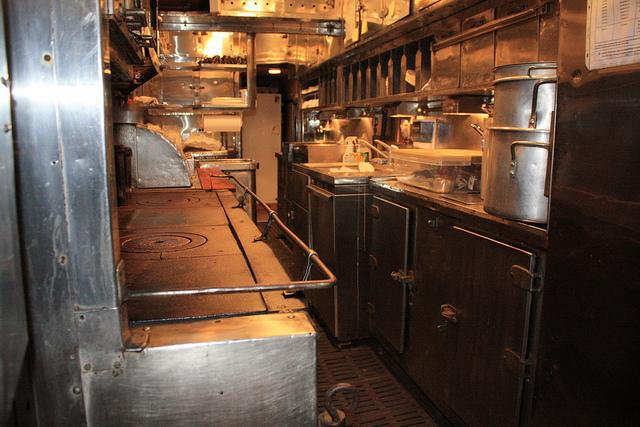What kind of setting is this venue? kitchen 